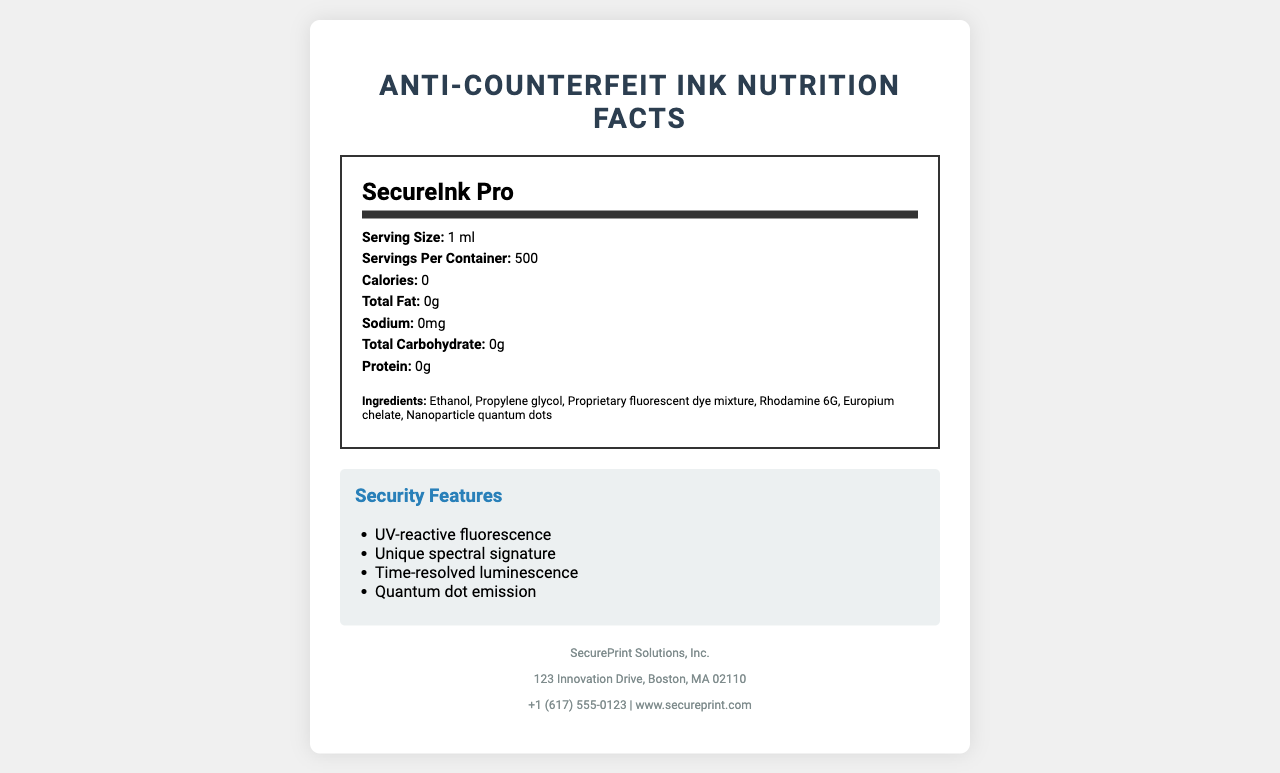who is the manufacturer of SecureInk Pro? The manufacturer information is listed near the bottom of the document.
Answer: SecurePrint Solutions, Inc. what is the serving size of SecureInk Pro? The serving size is explicitly mentioned in the nutrition facts section.
Answer: 1 ml what is the pH level of SecureInk Pro? The pH level is listed under the chemical properties section.
Answer: 7.2 how many servings per container does SecureInk Pro have? This information is given next to the serving size in the nutrition facts section.
Answer: 500 list one safety warning associated with SecureInk Pro. The safety warnings are listed below the storage instructions section.
Answer: Flammable liquid and vapor which of the following is an ingredient in SecureInk Pro? A. Water B. Ethanol C. Acetone D. Glycerin Ethanol is listed as the first ingredient in the ingredients list.
Answer: B. Ethanol how long is the shelf life of SecureInk Pro? The shelf life information is located in the storage instructions section.
Answer: 24 months can SecureInk Pro be used on glass? Glass is listed under the compatible substrates section.
Answer: Yes true or false: SecureInk Pro has a total fat content of 0g. The total fat content is listed as 0g in the nutritional content section.
Answer: True summarize the features and properties of SecureInk Pro. This document provides detailed information on the nutritional, chemical, and security features of SecureInk Pro, as well as safety, storage, and regulatory compliance data.
Answer: SecureInk Pro is an anti-counterfeit ink with zero calories and no nutritional content such as fats, carbohydrates, or proteins. It contains ingredients like ethanol, propylene glycol, and nanoparticle quantum dots. The ink has chemical properties including a pH of 7.2 and a density of 0.89 g/mL. It features multiple security advantages like UV-reactive fluorescence and quantum dot emission, and it is suitable for various substrates. It has a shelf life of 24 months and complies with standards like RoHS and FDA. Safety warnings include flammability and eye irritation risks. what company's contact number is mentioned? The manufacturer's contact number is found in the manufacturer info section.
Answer: +1 (617) 555-0123 what printing methods are compatible with SecureInk Pro? A. Inkjet printing B. Screen printing C. Flexographic printing D. All of the above All these printing methods are listed under application methods.
Answer: D. All of the above which of the following certifications does SecureInk Pro not have? A. ISO 9001:2015 B. RoHS compliant C. EPA registered D. OECD Guidelines for Multinational Enterprises The document does not mention EPA registration among the certifications.
Answer: C. EPA registered 